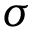<formula> <loc_0><loc_0><loc_500><loc_500>\sigma</formula> 